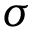<formula> <loc_0><loc_0><loc_500><loc_500>\sigma</formula> 